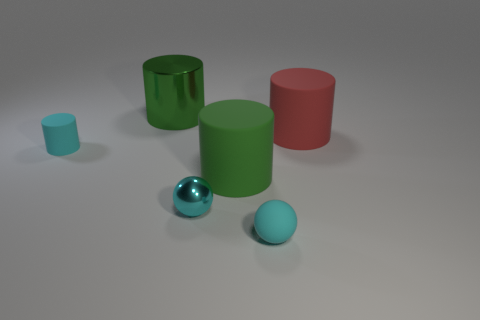Subtract all small cyan cylinders. How many cylinders are left? 3 Subtract all brown balls. How many green cylinders are left? 2 Subtract 2 cylinders. How many cylinders are left? 2 Subtract all cyan cylinders. How many cylinders are left? 3 Add 4 red matte objects. How many objects exist? 10 Subtract all cylinders. How many objects are left? 2 Subtract all blue cylinders. Subtract all purple blocks. How many cylinders are left? 4 Subtract all big purple spheres. Subtract all large rubber things. How many objects are left? 4 Add 1 small cyan cylinders. How many small cyan cylinders are left? 2 Add 3 cyan matte spheres. How many cyan matte spheres exist? 4 